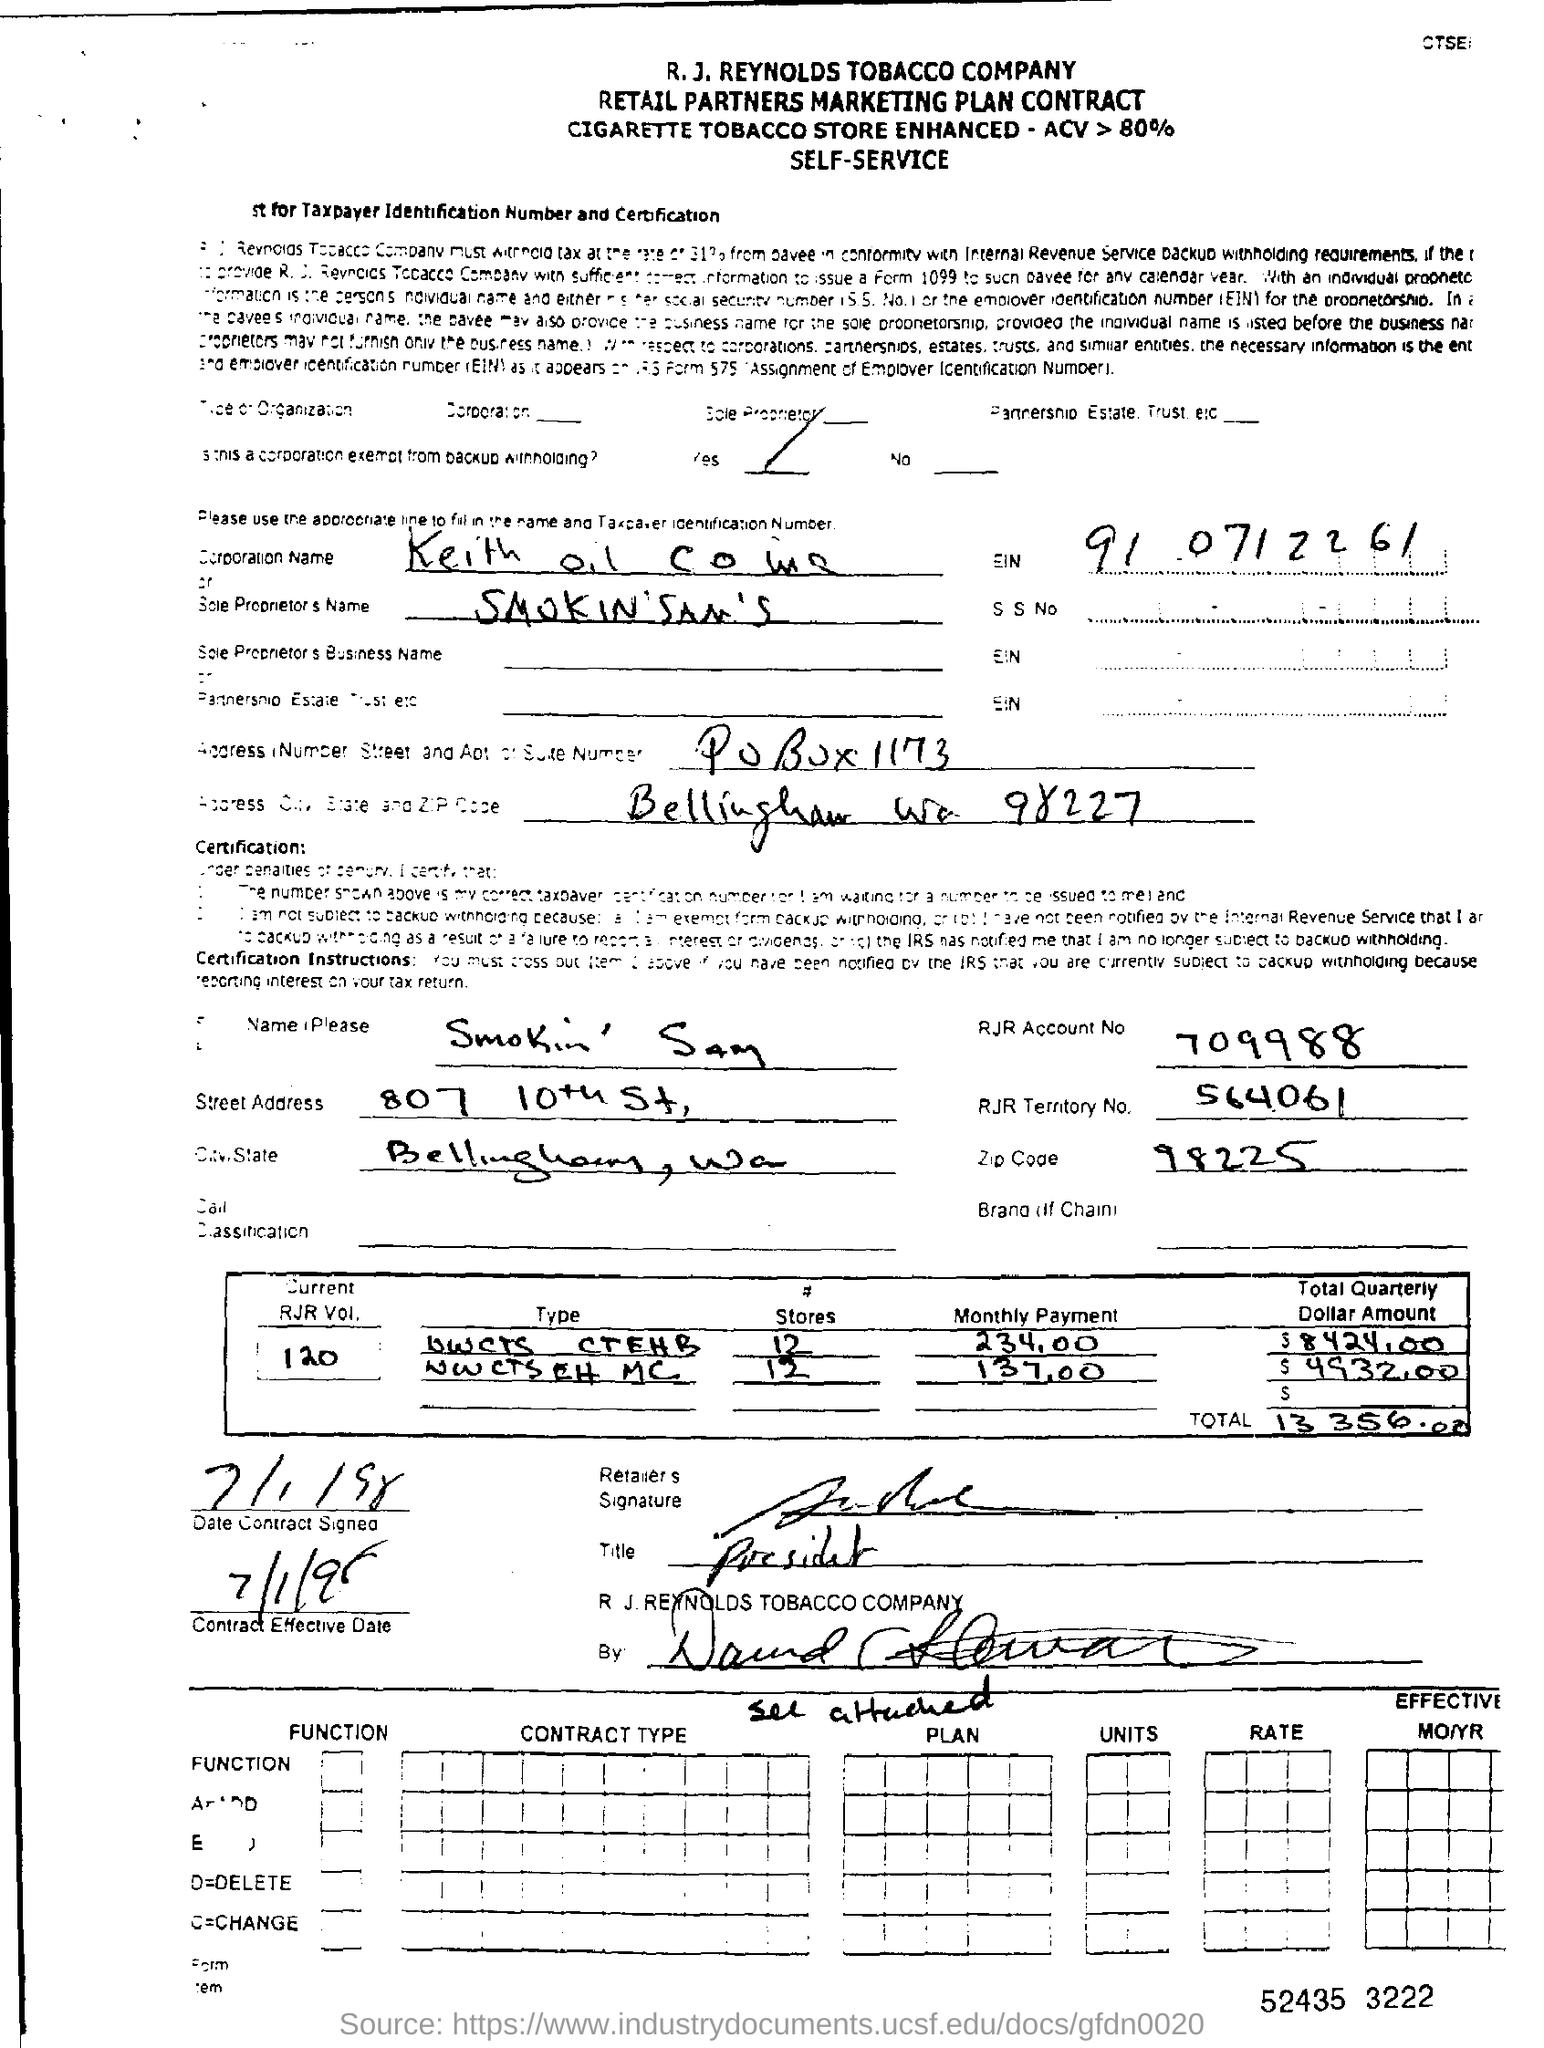What is the RJR Account No mentioned in the contract form?
 709988 